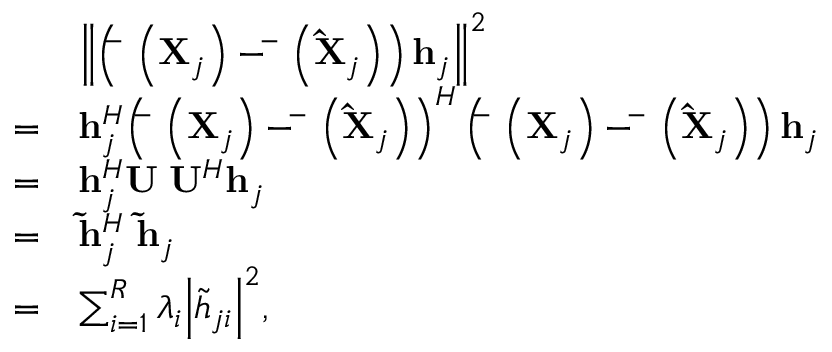<formula> <loc_0><loc_0><loc_500><loc_500>\begin{array} { r l } & { { \left \| { \left ( { { \bar { \Phi } } \left ( { { { X } _ { j } } } \right ) - { \bar { \Phi } } \left ( { { { { \hat { X } } } _ { j } } } \right ) } \right ) { { h } _ { j } } } \right \| ^ { 2 } } } \\ { = } & { { h } _ { j } ^ { H } { \left ( { { \bar { \Phi } } \left ( { { { X } _ { j } } } \right ) - { \bar { \Phi } } \left ( { { { { \hat { X } } } _ { j } } } \right ) } \right ) ^ { H } } \left ( { { \bar { \Phi } } \left ( { { { X } _ { j } } } \right ) - { \bar { \Phi } } \left ( { { { { \hat { X } } } _ { j } } } \right ) } \right ) { { h } _ { j } } } \\ { = } & { { h } _ { j } ^ { H } { U \Sigma } { { U } ^ { H } } { { h } _ { j } } } \\ { = } & { { \tilde { h } } _ { j } ^ { H } { \Sigma } { { { \tilde { h } } } _ { j } } } \\ { = } & { \sum _ { i = 1 } ^ { R } { { \lambda _ { i } } { { \left | { { { \tilde { h } } _ { j i } } } \right | } ^ { 2 } } } , } \end{array}</formula> 